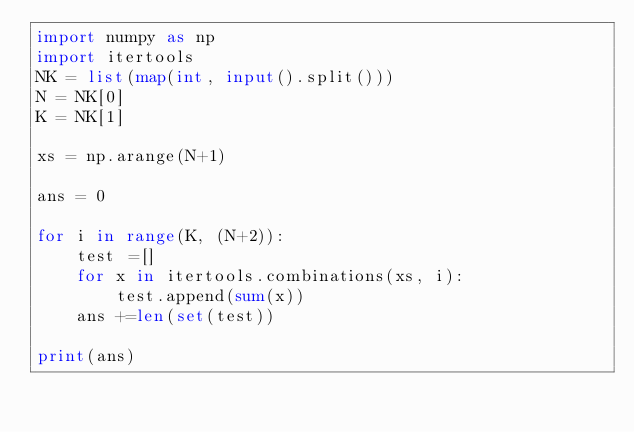<code> <loc_0><loc_0><loc_500><loc_500><_Python_>import numpy as np
import itertools
NK = list(map(int, input().split()))
N = NK[0]
K = NK[1]

xs = np.arange(N+1)

ans = 0

for i in range(K, (N+2)):
    test =[]
    for x in itertools.combinations(xs, i):
        test.append(sum(x))
    ans +=len(set(test))
    
print(ans)</code> 